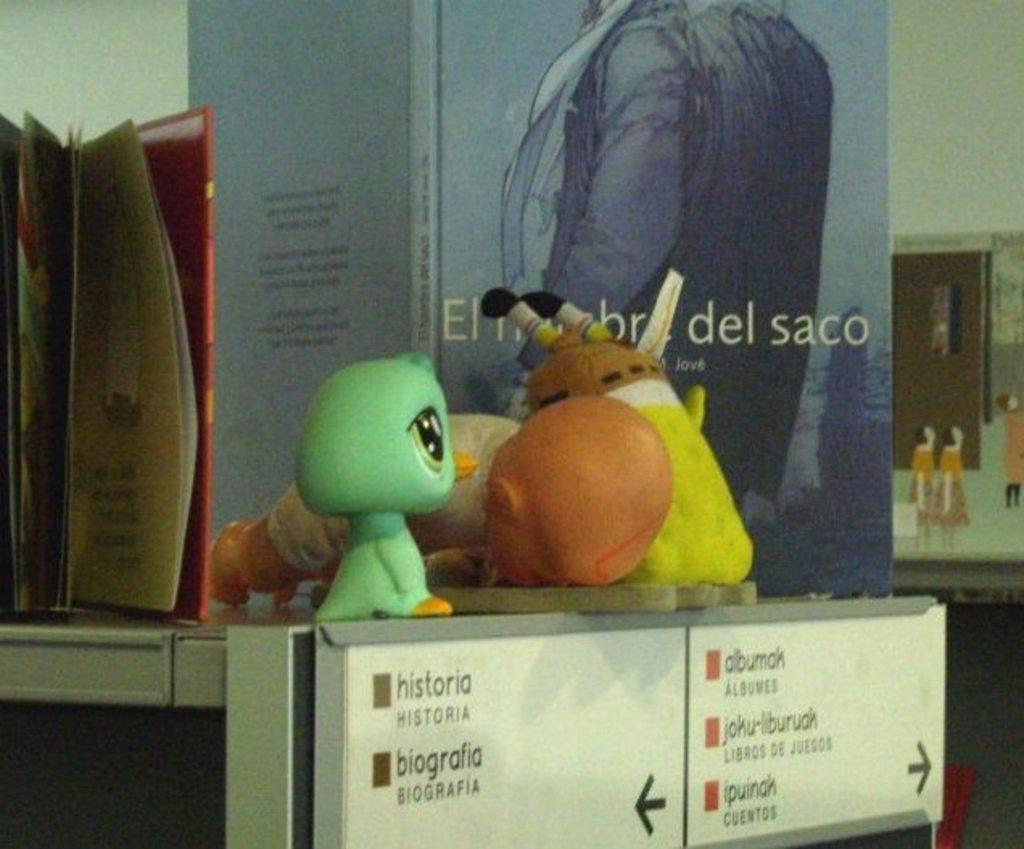What is placed on the rack in the image? There are toys placed on the rack, as well as objects that look like books. Is there any text visible in the image? Yes, there is a board attached to the rack with some text. How many wings can be seen on the toys in the image? There are no wings visible on the toys in the image. What color is the umbrella held by the toy in the image? There is no umbrella present in the image. 